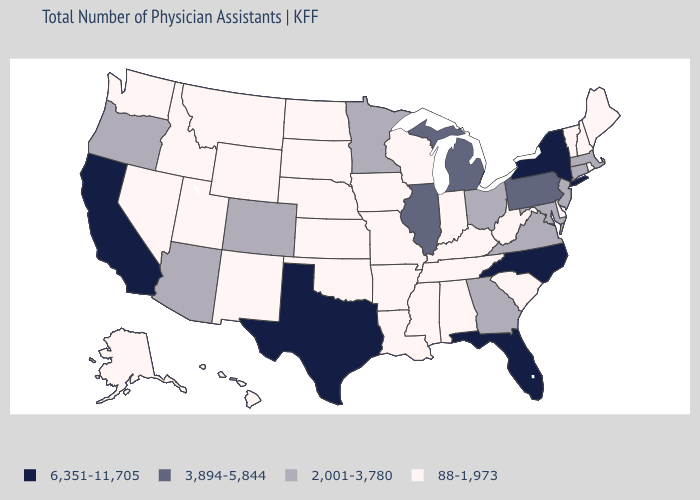Does Wisconsin have a higher value than Mississippi?
Concise answer only. No. Does Missouri have the same value as Arizona?
Answer briefly. No. How many symbols are there in the legend?
Concise answer only. 4. How many symbols are there in the legend?
Keep it brief. 4. What is the lowest value in the Northeast?
Be succinct. 88-1,973. What is the value of Hawaii?
Quick response, please. 88-1,973. Does the first symbol in the legend represent the smallest category?
Give a very brief answer. No. Does Maine have a higher value than Virginia?
Answer briefly. No. What is the value of Alabama?
Be succinct. 88-1,973. What is the value of Massachusetts?
Be succinct. 2,001-3,780. Among the states that border New Jersey , which have the highest value?
Short answer required. New York. Does Maine have a lower value than Colorado?
Be succinct. Yes. Does Michigan have the highest value in the MidWest?
Quick response, please. Yes. What is the value of New Hampshire?
Quick response, please. 88-1,973. 